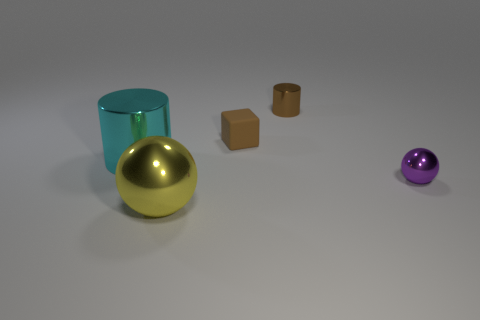Is the size of the purple thing the same as the thing behind the brown matte object?
Give a very brief answer. Yes. What number of objects are either small things or small brown blocks?
Make the answer very short. 3. Is there a small cylinder that has the same material as the cyan thing?
Provide a succinct answer. Yes. What is the size of the metallic object that is the same color as the block?
Offer a terse response. Small. What color is the large metallic thing behind the yellow metal object on the left side of the small rubber thing?
Offer a very short reply. Cyan. Do the brown matte object and the brown cylinder have the same size?
Ensure brevity in your answer.  Yes. What number of cubes are brown metal objects or cyan metallic things?
Your answer should be very brief. 0. What number of metal objects are left of the sphere on the right side of the small brown rubber cube?
Provide a short and direct response. 3. Is the purple object the same shape as the cyan metallic object?
Make the answer very short. No. There is another shiny thing that is the same shape as the purple metal object; what size is it?
Your response must be concise. Large. 